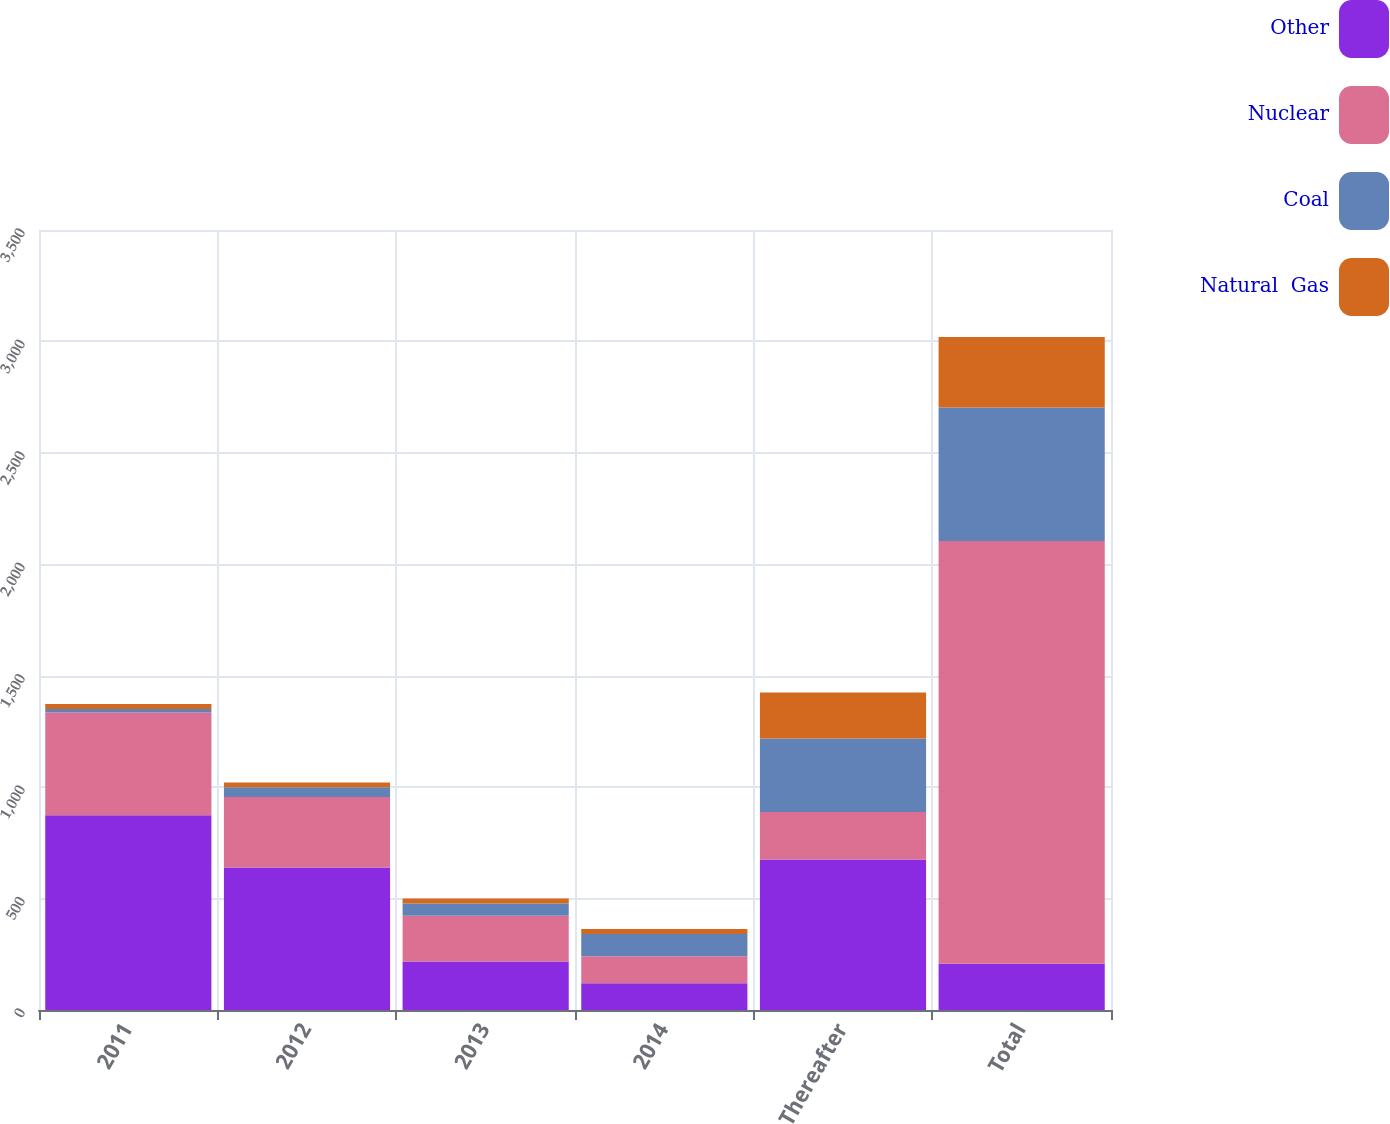Convert chart. <chart><loc_0><loc_0><loc_500><loc_500><stacked_bar_chart><ecel><fcel>2011<fcel>2012<fcel>2013<fcel>2014<fcel>Thereafter<fcel>Total<nl><fcel>Other<fcel>874<fcel>639<fcel>218<fcel>120<fcel>675<fcel>207<nl><fcel>Nuclear<fcel>461<fcel>317<fcel>205<fcel>121<fcel>214<fcel>1898<nl><fcel>Coal<fcel>16<fcel>43<fcel>55<fcel>100<fcel>329<fcel>598<nl><fcel>Natural  Gas<fcel>22<fcel>22<fcel>22<fcel>22<fcel>207<fcel>317<nl></chart> 